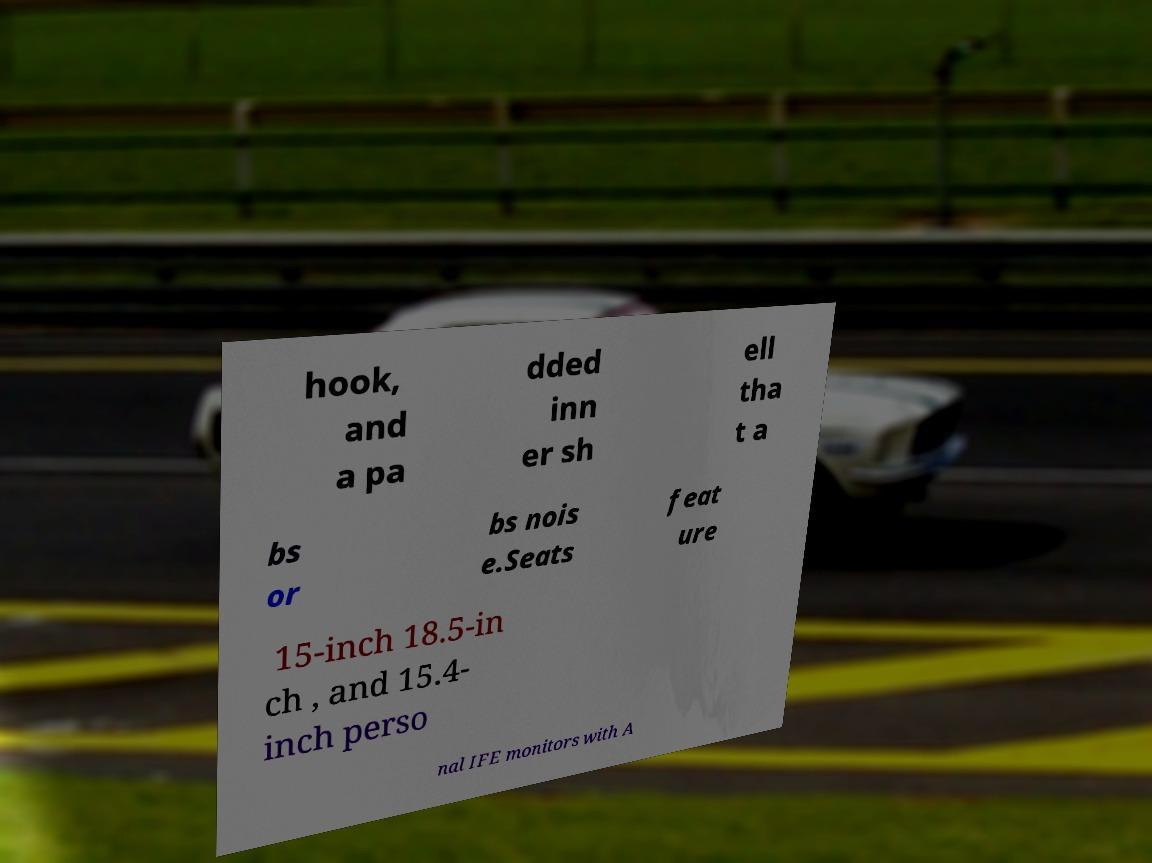I need the written content from this picture converted into text. Can you do that? hook, and a pa dded inn er sh ell tha t a bs or bs nois e.Seats feat ure 15-inch 18.5-in ch , and 15.4- inch perso nal IFE monitors with A 